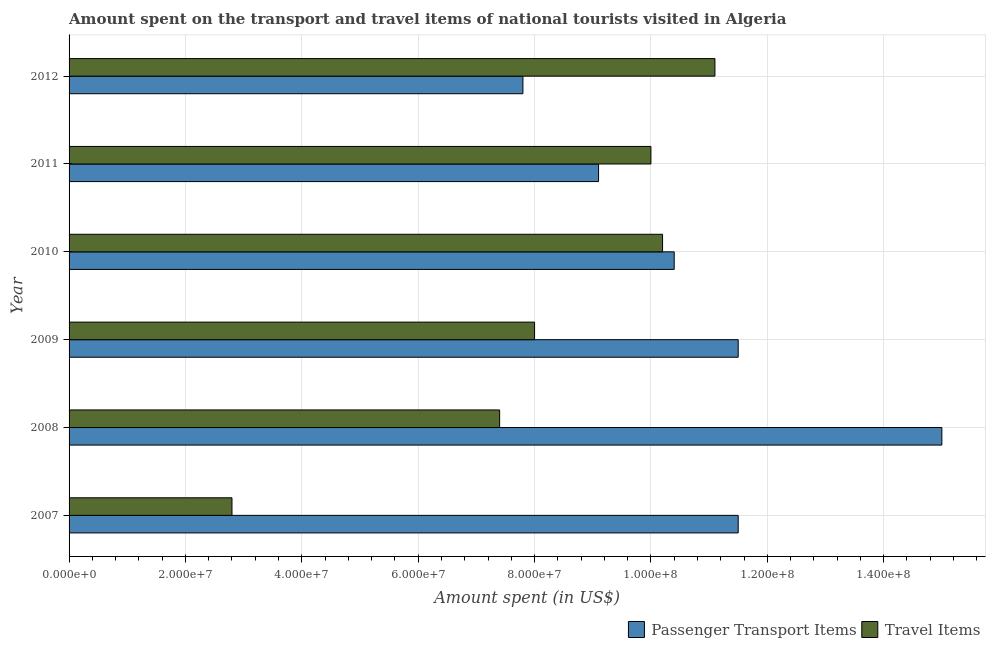How many different coloured bars are there?
Your answer should be compact. 2. How many groups of bars are there?
Give a very brief answer. 6. Are the number of bars on each tick of the Y-axis equal?
Give a very brief answer. Yes. How many bars are there on the 4th tick from the top?
Give a very brief answer. 2. How many bars are there on the 3rd tick from the bottom?
Offer a terse response. 2. What is the label of the 5th group of bars from the top?
Make the answer very short. 2008. In how many cases, is the number of bars for a given year not equal to the number of legend labels?
Offer a very short reply. 0. What is the amount spent on passenger transport items in 2008?
Keep it short and to the point. 1.50e+08. Across all years, what is the maximum amount spent in travel items?
Ensure brevity in your answer.  1.11e+08. Across all years, what is the minimum amount spent in travel items?
Offer a very short reply. 2.80e+07. In which year was the amount spent in travel items minimum?
Give a very brief answer. 2007. What is the total amount spent on passenger transport items in the graph?
Ensure brevity in your answer.  6.53e+08. What is the difference between the amount spent on passenger transport items in 2007 and that in 2010?
Your answer should be compact. 1.10e+07. What is the difference between the amount spent in travel items in 2009 and the amount spent on passenger transport items in 2007?
Provide a short and direct response. -3.50e+07. What is the average amount spent on passenger transport items per year?
Make the answer very short. 1.09e+08. In the year 2011, what is the difference between the amount spent on passenger transport items and amount spent in travel items?
Offer a terse response. -9.00e+06. In how many years, is the amount spent on passenger transport items greater than 40000000 US$?
Your answer should be very brief. 6. What is the ratio of the amount spent on passenger transport items in 2008 to that in 2010?
Make the answer very short. 1.44. Is the difference between the amount spent in travel items in 2007 and 2010 greater than the difference between the amount spent on passenger transport items in 2007 and 2010?
Your response must be concise. No. What is the difference between the highest and the second highest amount spent in travel items?
Ensure brevity in your answer.  9.00e+06. What is the difference between the highest and the lowest amount spent in travel items?
Provide a short and direct response. 8.30e+07. In how many years, is the amount spent on passenger transport items greater than the average amount spent on passenger transport items taken over all years?
Your answer should be compact. 3. What does the 1st bar from the top in 2007 represents?
Your response must be concise. Travel Items. What does the 1st bar from the bottom in 2008 represents?
Your answer should be compact. Passenger Transport Items. How many bars are there?
Your answer should be very brief. 12. Are all the bars in the graph horizontal?
Your answer should be compact. Yes. How many years are there in the graph?
Give a very brief answer. 6. Are the values on the major ticks of X-axis written in scientific E-notation?
Your response must be concise. Yes. Does the graph contain grids?
Provide a succinct answer. Yes. Where does the legend appear in the graph?
Your answer should be compact. Bottom right. How many legend labels are there?
Make the answer very short. 2. What is the title of the graph?
Your answer should be compact. Amount spent on the transport and travel items of national tourists visited in Algeria. What is the label or title of the X-axis?
Your answer should be compact. Amount spent (in US$). What is the label or title of the Y-axis?
Offer a terse response. Year. What is the Amount spent (in US$) of Passenger Transport Items in 2007?
Your response must be concise. 1.15e+08. What is the Amount spent (in US$) in Travel Items in 2007?
Your answer should be compact. 2.80e+07. What is the Amount spent (in US$) in Passenger Transport Items in 2008?
Give a very brief answer. 1.50e+08. What is the Amount spent (in US$) in Travel Items in 2008?
Your answer should be very brief. 7.40e+07. What is the Amount spent (in US$) of Passenger Transport Items in 2009?
Offer a very short reply. 1.15e+08. What is the Amount spent (in US$) in Travel Items in 2009?
Offer a very short reply. 8.00e+07. What is the Amount spent (in US$) of Passenger Transport Items in 2010?
Offer a terse response. 1.04e+08. What is the Amount spent (in US$) in Travel Items in 2010?
Your answer should be very brief. 1.02e+08. What is the Amount spent (in US$) of Passenger Transport Items in 2011?
Provide a succinct answer. 9.10e+07. What is the Amount spent (in US$) in Travel Items in 2011?
Give a very brief answer. 1.00e+08. What is the Amount spent (in US$) in Passenger Transport Items in 2012?
Ensure brevity in your answer.  7.80e+07. What is the Amount spent (in US$) of Travel Items in 2012?
Your answer should be very brief. 1.11e+08. Across all years, what is the maximum Amount spent (in US$) in Passenger Transport Items?
Provide a short and direct response. 1.50e+08. Across all years, what is the maximum Amount spent (in US$) of Travel Items?
Your answer should be very brief. 1.11e+08. Across all years, what is the minimum Amount spent (in US$) in Passenger Transport Items?
Keep it short and to the point. 7.80e+07. Across all years, what is the minimum Amount spent (in US$) in Travel Items?
Provide a short and direct response. 2.80e+07. What is the total Amount spent (in US$) in Passenger Transport Items in the graph?
Provide a short and direct response. 6.53e+08. What is the total Amount spent (in US$) of Travel Items in the graph?
Offer a very short reply. 4.95e+08. What is the difference between the Amount spent (in US$) in Passenger Transport Items in 2007 and that in 2008?
Give a very brief answer. -3.50e+07. What is the difference between the Amount spent (in US$) in Travel Items in 2007 and that in 2008?
Make the answer very short. -4.60e+07. What is the difference between the Amount spent (in US$) of Passenger Transport Items in 2007 and that in 2009?
Ensure brevity in your answer.  0. What is the difference between the Amount spent (in US$) in Travel Items in 2007 and that in 2009?
Your response must be concise. -5.20e+07. What is the difference between the Amount spent (in US$) in Passenger Transport Items in 2007 and that in 2010?
Your answer should be compact. 1.10e+07. What is the difference between the Amount spent (in US$) in Travel Items in 2007 and that in 2010?
Offer a terse response. -7.40e+07. What is the difference between the Amount spent (in US$) of Passenger Transport Items in 2007 and that in 2011?
Give a very brief answer. 2.40e+07. What is the difference between the Amount spent (in US$) in Travel Items in 2007 and that in 2011?
Your response must be concise. -7.20e+07. What is the difference between the Amount spent (in US$) in Passenger Transport Items in 2007 and that in 2012?
Your answer should be compact. 3.70e+07. What is the difference between the Amount spent (in US$) in Travel Items in 2007 and that in 2012?
Give a very brief answer. -8.30e+07. What is the difference between the Amount spent (in US$) in Passenger Transport Items in 2008 and that in 2009?
Give a very brief answer. 3.50e+07. What is the difference between the Amount spent (in US$) of Travel Items in 2008 and that in 2009?
Your answer should be compact. -6.00e+06. What is the difference between the Amount spent (in US$) in Passenger Transport Items in 2008 and that in 2010?
Offer a very short reply. 4.60e+07. What is the difference between the Amount spent (in US$) in Travel Items in 2008 and that in 2010?
Give a very brief answer. -2.80e+07. What is the difference between the Amount spent (in US$) of Passenger Transport Items in 2008 and that in 2011?
Your answer should be compact. 5.90e+07. What is the difference between the Amount spent (in US$) in Travel Items in 2008 and that in 2011?
Your response must be concise. -2.60e+07. What is the difference between the Amount spent (in US$) in Passenger Transport Items in 2008 and that in 2012?
Offer a very short reply. 7.20e+07. What is the difference between the Amount spent (in US$) of Travel Items in 2008 and that in 2012?
Your response must be concise. -3.70e+07. What is the difference between the Amount spent (in US$) in Passenger Transport Items in 2009 and that in 2010?
Make the answer very short. 1.10e+07. What is the difference between the Amount spent (in US$) of Travel Items in 2009 and that in 2010?
Provide a short and direct response. -2.20e+07. What is the difference between the Amount spent (in US$) of Passenger Transport Items in 2009 and that in 2011?
Ensure brevity in your answer.  2.40e+07. What is the difference between the Amount spent (in US$) in Travel Items in 2009 and that in 2011?
Offer a terse response. -2.00e+07. What is the difference between the Amount spent (in US$) of Passenger Transport Items in 2009 and that in 2012?
Provide a succinct answer. 3.70e+07. What is the difference between the Amount spent (in US$) in Travel Items in 2009 and that in 2012?
Your answer should be very brief. -3.10e+07. What is the difference between the Amount spent (in US$) in Passenger Transport Items in 2010 and that in 2011?
Keep it short and to the point. 1.30e+07. What is the difference between the Amount spent (in US$) in Travel Items in 2010 and that in 2011?
Make the answer very short. 2.00e+06. What is the difference between the Amount spent (in US$) in Passenger Transport Items in 2010 and that in 2012?
Make the answer very short. 2.60e+07. What is the difference between the Amount spent (in US$) in Travel Items in 2010 and that in 2012?
Offer a terse response. -9.00e+06. What is the difference between the Amount spent (in US$) of Passenger Transport Items in 2011 and that in 2012?
Keep it short and to the point. 1.30e+07. What is the difference between the Amount spent (in US$) in Travel Items in 2011 and that in 2012?
Provide a short and direct response. -1.10e+07. What is the difference between the Amount spent (in US$) in Passenger Transport Items in 2007 and the Amount spent (in US$) in Travel Items in 2008?
Offer a very short reply. 4.10e+07. What is the difference between the Amount spent (in US$) of Passenger Transport Items in 2007 and the Amount spent (in US$) of Travel Items in 2009?
Your answer should be very brief. 3.50e+07. What is the difference between the Amount spent (in US$) of Passenger Transport Items in 2007 and the Amount spent (in US$) of Travel Items in 2010?
Ensure brevity in your answer.  1.30e+07. What is the difference between the Amount spent (in US$) in Passenger Transport Items in 2007 and the Amount spent (in US$) in Travel Items in 2011?
Your answer should be very brief. 1.50e+07. What is the difference between the Amount spent (in US$) of Passenger Transport Items in 2007 and the Amount spent (in US$) of Travel Items in 2012?
Make the answer very short. 4.00e+06. What is the difference between the Amount spent (in US$) of Passenger Transport Items in 2008 and the Amount spent (in US$) of Travel Items in 2009?
Your answer should be very brief. 7.00e+07. What is the difference between the Amount spent (in US$) in Passenger Transport Items in 2008 and the Amount spent (in US$) in Travel Items in 2010?
Offer a terse response. 4.80e+07. What is the difference between the Amount spent (in US$) of Passenger Transport Items in 2008 and the Amount spent (in US$) of Travel Items in 2011?
Make the answer very short. 5.00e+07. What is the difference between the Amount spent (in US$) in Passenger Transport Items in 2008 and the Amount spent (in US$) in Travel Items in 2012?
Keep it short and to the point. 3.90e+07. What is the difference between the Amount spent (in US$) in Passenger Transport Items in 2009 and the Amount spent (in US$) in Travel Items in 2010?
Provide a short and direct response. 1.30e+07. What is the difference between the Amount spent (in US$) of Passenger Transport Items in 2009 and the Amount spent (in US$) of Travel Items in 2011?
Ensure brevity in your answer.  1.50e+07. What is the difference between the Amount spent (in US$) in Passenger Transport Items in 2010 and the Amount spent (in US$) in Travel Items in 2012?
Provide a succinct answer. -7.00e+06. What is the difference between the Amount spent (in US$) in Passenger Transport Items in 2011 and the Amount spent (in US$) in Travel Items in 2012?
Provide a succinct answer. -2.00e+07. What is the average Amount spent (in US$) of Passenger Transport Items per year?
Your answer should be compact. 1.09e+08. What is the average Amount spent (in US$) in Travel Items per year?
Keep it short and to the point. 8.25e+07. In the year 2007, what is the difference between the Amount spent (in US$) in Passenger Transport Items and Amount spent (in US$) in Travel Items?
Give a very brief answer. 8.70e+07. In the year 2008, what is the difference between the Amount spent (in US$) of Passenger Transport Items and Amount spent (in US$) of Travel Items?
Your answer should be very brief. 7.60e+07. In the year 2009, what is the difference between the Amount spent (in US$) in Passenger Transport Items and Amount spent (in US$) in Travel Items?
Offer a terse response. 3.50e+07. In the year 2010, what is the difference between the Amount spent (in US$) of Passenger Transport Items and Amount spent (in US$) of Travel Items?
Your answer should be very brief. 2.00e+06. In the year 2011, what is the difference between the Amount spent (in US$) of Passenger Transport Items and Amount spent (in US$) of Travel Items?
Give a very brief answer. -9.00e+06. In the year 2012, what is the difference between the Amount spent (in US$) in Passenger Transport Items and Amount spent (in US$) in Travel Items?
Your response must be concise. -3.30e+07. What is the ratio of the Amount spent (in US$) in Passenger Transport Items in 2007 to that in 2008?
Your response must be concise. 0.77. What is the ratio of the Amount spent (in US$) in Travel Items in 2007 to that in 2008?
Your answer should be compact. 0.38. What is the ratio of the Amount spent (in US$) of Passenger Transport Items in 2007 to that in 2009?
Your answer should be very brief. 1. What is the ratio of the Amount spent (in US$) of Travel Items in 2007 to that in 2009?
Your answer should be compact. 0.35. What is the ratio of the Amount spent (in US$) of Passenger Transport Items in 2007 to that in 2010?
Keep it short and to the point. 1.11. What is the ratio of the Amount spent (in US$) of Travel Items in 2007 to that in 2010?
Your answer should be very brief. 0.27. What is the ratio of the Amount spent (in US$) in Passenger Transport Items in 2007 to that in 2011?
Offer a very short reply. 1.26. What is the ratio of the Amount spent (in US$) of Travel Items in 2007 to that in 2011?
Provide a short and direct response. 0.28. What is the ratio of the Amount spent (in US$) in Passenger Transport Items in 2007 to that in 2012?
Your response must be concise. 1.47. What is the ratio of the Amount spent (in US$) in Travel Items in 2007 to that in 2012?
Make the answer very short. 0.25. What is the ratio of the Amount spent (in US$) in Passenger Transport Items in 2008 to that in 2009?
Keep it short and to the point. 1.3. What is the ratio of the Amount spent (in US$) in Travel Items in 2008 to that in 2009?
Give a very brief answer. 0.93. What is the ratio of the Amount spent (in US$) in Passenger Transport Items in 2008 to that in 2010?
Your answer should be compact. 1.44. What is the ratio of the Amount spent (in US$) of Travel Items in 2008 to that in 2010?
Keep it short and to the point. 0.73. What is the ratio of the Amount spent (in US$) in Passenger Transport Items in 2008 to that in 2011?
Ensure brevity in your answer.  1.65. What is the ratio of the Amount spent (in US$) of Travel Items in 2008 to that in 2011?
Provide a short and direct response. 0.74. What is the ratio of the Amount spent (in US$) in Passenger Transport Items in 2008 to that in 2012?
Your answer should be very brief. 1.92. What is the ratio of the Amount spent (in US$) in Passenger Transport Items in 2009 to that in 2010?
Make the answer very short. 1.11. What is the ratio of the Amount spent (in US$) in Travel Items in 2009 to that in 2010?
Your answer should be compact. 0.78. What is the ratio of the Amount spent (in US$) in Passenger Transport Items in 2009 to that in 2011?
Give a very brief answer. 1.26. What is the ratio of the Amount spent (in US$) in Travel Items in 2009 to that in 2011?
Give a very brief answer. 0.8. What is the ratio of the Amount spent (in US$) in Passenger Transport Items in 2009 to that in 2012?
Your answer should be compact. 1.47. What is the ratio of the Amount spent (in US$) in Travel Items in 2009 to that in 2012?
Offer a terse response. 0.72. What is the ratio of the Amount spent (in US$) in Travel Items in 2010 to that in 2011?
Provide a succinct answer. 1.02. What is the ratio of the Amount spent (in US$) of Passenger Transport Items in 2010 to that in 2012?
Your answer should be compact. 1.33. What is the ratio of the Amount spent (in US$) in Travel Items in 2010 to that in 2012?
Make the answer very short. 0.92. What is the ratio of the Amount spent (in US$) of Travel Items in 2011 to that in 2012?
Your answer should be very brief. 0.9. What is the difference between the highest and the second highest Amount spent (in US$) in Passenger Transport Items?
Provide a succinct answer. 3.50e+07. What is the difference between the highest and the second highest Amount spent (in US$) in Travel Items?
Offer a terse response. 9.00e+06. What is the difference between the highest and the lowest Amount spent (in US$) in Passenger Transport Items?
Keep it short and to the point. 7.20e+07. What is the difference between the highest and the lowest Amount spent (in US$) of Travel Items?
Offer a very short reply. 8.30e+07. 